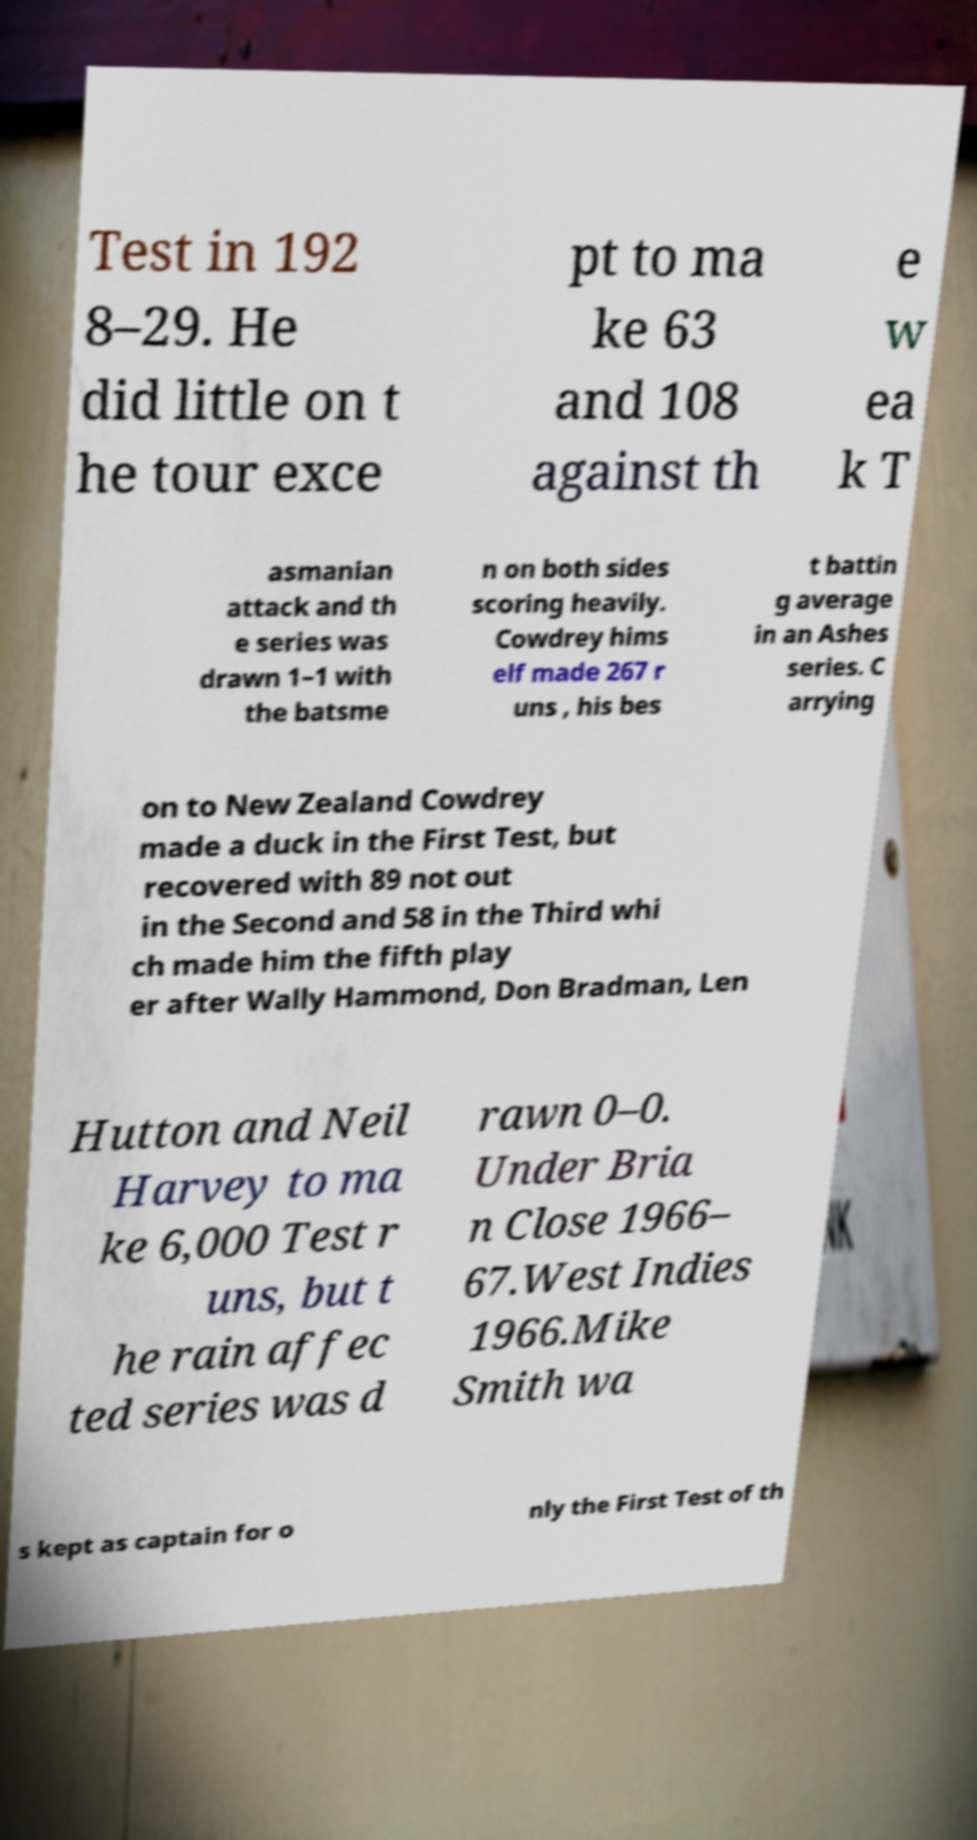What messages or text are displayed in this image? I need them in a readable, typed format. Test in 192 8–29. He did little on t he tour exce pt to ma ke 63 and 108 against th e w ea k T asmanian attack and th e series was drawn 1–1 with the batsme n on both sides scoring heavily. Cowdrey hims elf made 267 r uns , his bes t battin g average in an Ashes series. C arrying on to New Zealand Cowdrey made a duck in the First Test, but recovered with 89 not out in the Second and 58 in the Third whi ch made him the fifth play er after Wally Hammond, Don Bradman, Len Hutton and Neil Harvey to ma ke 6,000 Test r uns, but t he rain affec ted series was d rawn 0–0. Under Bria n Close 1966– 67.West Indies 1966.Mike Smith wa s kept as captain for o nly the First Test of th 